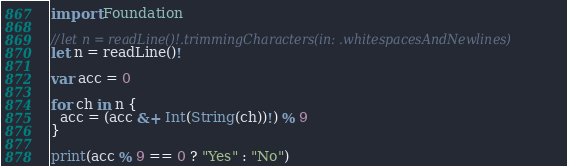<code> <loc_0><loc_0><loc_500><loc_500><_Swift_>import Foundation

//let n = readLine()!.trimmingCharacters(in: .whitespacesAndNewlines)
let n = readLine()!

var acc = 0

for ch in n {
  acc = (acc &+ Int(String(ch))!) % 9
}

print(acc % 9 == 0 ? "Yes" : "No")
</code> 